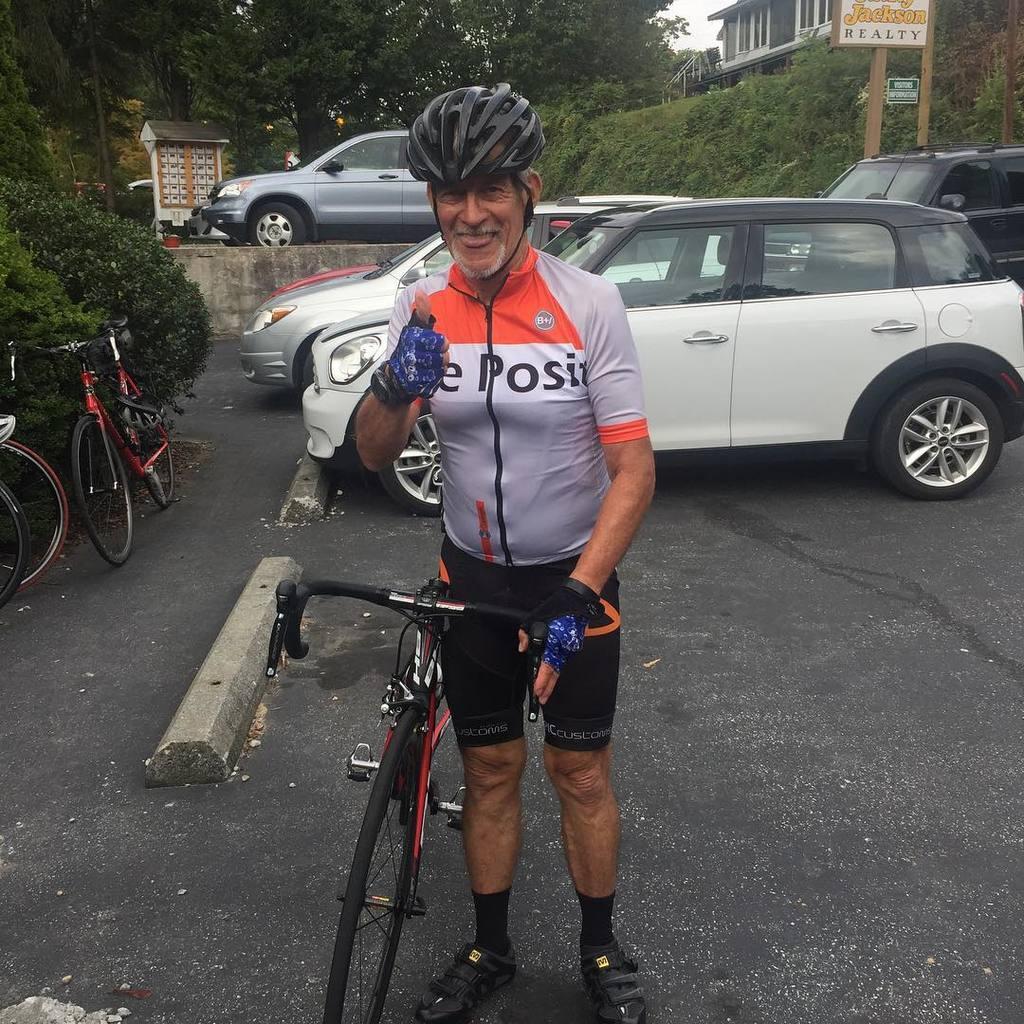Can you describe this image briefly? This image consists of a man wearing a jersey and a helmet is standing on the road. Beside him, there is a cycle. In the background, there are cars and cycles along with the trees. On the right, there is a building. At the bottom, there is a road. 